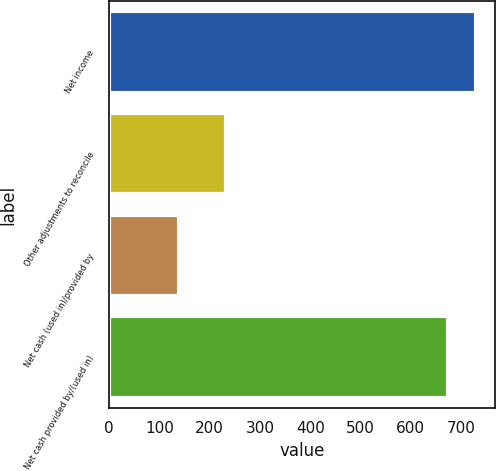Convert chart. <chart><loc_0><loc_0><loc_500><loc_500><bar_chart><fcel>Net income<fcel>Other adjustments to reconcile<fcel>Net cash (used in)/provided by<fcel>Net cash provided by/(used in)<nl><fcel>730.7<fcel>231.4<fcel>138.4<fcel>673.6<nl></chart> 